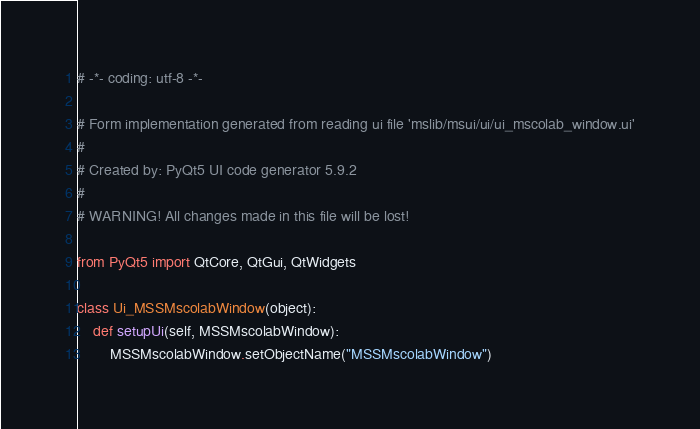Convert code to text. <code><loc_0><loc_0><loc_500><loc_500><_Python_># -*- coding: utf-8 -*-

# Form implementation generated from reading ui file 'mslib/msui/ui/ui_mscolab_window.ui'
#
# Created by: PyQt5 UI code generator 5.9.2
#
# WARNING! All changes made in this file will be lost!

from PyQt5 import QtCore, QtGui, QtWidgets

class Ui_MSSMscolabWindow(object):
    def setupUi(self, MSSMscolabWindow):
        MSSMscolabWindow.setObjectName("MSSMscolabWindow")</code> 